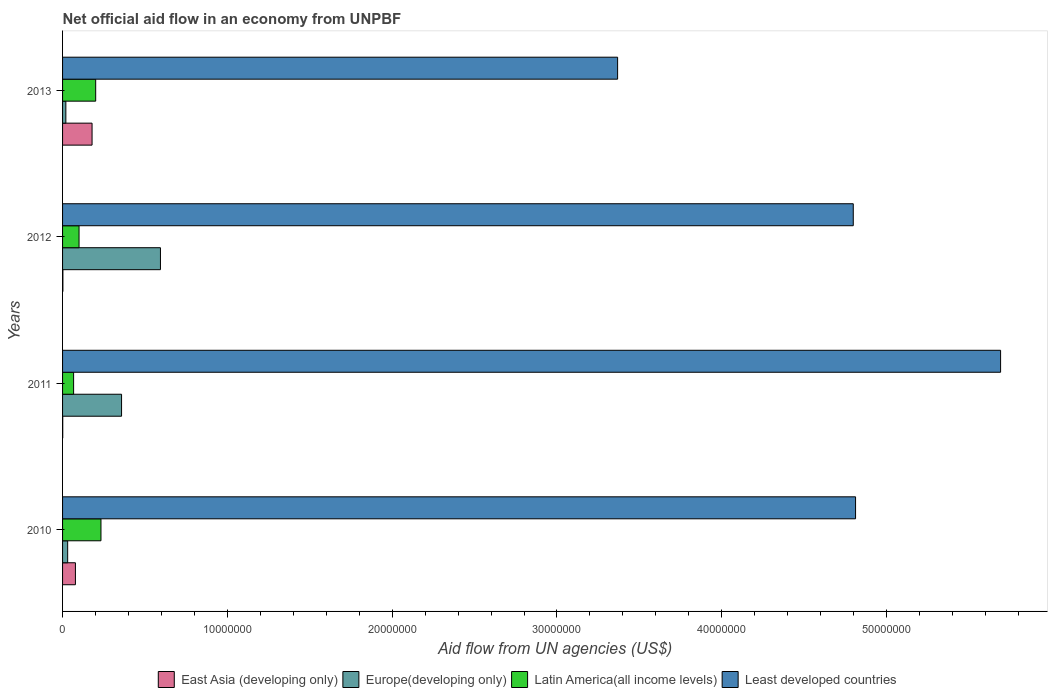How many groups of bars are there?
Offer a terse response. 4. How many bars are there on the 1st tick from the top?
Provide a short and direct response. 4. How many bars are there on the 3rd tick from the bottom?
Ensure brevity in your answer.  4. What is the label of the 3rd group of bars from the top?
Your answer should be very brief. 2011. What is the net official aid flow in Latin America(all income levels) in 2010?
Provide a short and direct response. 2.33e+06. Across all years, what is the maximum net official aid flow in Latin America(all income levels)?
Provide a short and direct response. 2.33e+06. Across all years, what is the minimum net official aid flow in East Asia (developing only)?
Your answer should be very brief. 10000. In which year was the net official aid flow in Latin America(all income levels) maximum?
Keep it short and to the point. 2010. In which year was the net official aid flow in Least developed countries minimum?
Your answer should be compact. 2013. What is the total net official aid flow in East Asia (developing only) in the graph?
Your answer should be very brief. 2.60e+06. What is the difference between the net official aid flow in Europe(developing only) in 2010 and that in 2013?
Offer a terse response. 1.10e+05. What is the difference between the net official aid flow in Europe(developing only) in 2013 and the net official aid flow in Latin America(all income levels) in 2012?
Provide a short and direct response. -8.00e+05. What is the average net official aid flow in Least developed countries per year?
Your answer should be compact. 4.67e+07. In the year 2011, what is the difference between the net official aid flow in East Asia (developing only) and net official aid flow in Least developed countries?
Make the answer very short. -5.69e+07. What is the ratio of the net official aid flow in Least developed countries in 2010 to that in 2013?
Offer a very short reply. 1.43. Is the net official aid flow in Least developed countries in 2011 less than that in 2012?
Keep it short and to the point. No. What is the difference between the highest and the second highest net official aid flow in Least developed countries?
Provide a succinct answer. 8.80e+06. What is the difference between the highest and the lowest net official aid flow in Latin America(all income levels)?
Ensure brevity in your answer.  1.66e+06. Is it the case that in every year, the sum of the net official aid flow in Latin America(all income levels) and net official aid flow in East Asia (developing only) is greater than the sum of net official aid flow in Least developed countries and net official aid flow in Europe(developing only)?
Offer a terse response. No. What does the 4th bar from the top in 2010 represents?
Offer a terse response. East Asia (developing only). What does the 4th bar from the bottom in 2012 represents?
Offer a very short reply. Least developed countries. Is it the case that in every year, the sum of the net official aid flow in East Asia (developing only) and net official aid flow in Latin America(all income levels) is greater than the net official aid flow in Least developed countries?
Your answer should be compact. No. Are all the bars in the graph horizontal?
Your response must be concise. Yes. How many years are there in the graph?
Your response must be concise. 4. What is the difference between two consecutive major ticks on the X-axis?
Offer a terse response. 1.00e+07. Are the values on the major ticks of X-axis written in scientific E-notation?
Provide a short and direct response. No. Does the graph contain any zero values?
Provide a short and direct response. No. Where does the legend appear in the graph?
Your answer should be compact. Bottom center. What is the title of the graph?
Offer a terse response. Net official aid flow in an economy from UNPBF. What is the label or title of the X-axis?
Provide a succinct answer. Aid flow from UN agencies (US$). What is the label or title of the Y-axis?
Offer a very short reply. Years. What is the Aid flow from UN agencies (US$) of East Asia (developing only) in 2010?
Keep it short and to the point. 7.80e+05. What is the Aid flow from UN agencies (US$) of Europe(developing only) in 2010?
Offer a very short reply. 3.10e+05. What is the Aid flow from UN agencies (US$) in Latin America(all income levels) in 2010?
Your answer should be compact. 2.33e+06. What is the Aid flow from UN agencies (US$) in Least developed countries in 2010?
Offer a very short reply. 4.81e+07. What is the Aid flow from UN agencies (US$) of East Asia (developing only) in 2011?
Your answer should be very brief. 10000. What is the Aid flow from UN agencies (US$) in Europe(developing only) in 2011?
Offer a terse response. 3.58e+06. What is the Aid flow from UN agencies (US$) of Latin America(all income levels) in 2011?
Provide a succinct answer. 6.70e+05. What is the Aid flow from UN agencies (US$) of Least developed countries in 2011?
Ensure brevity in your answer.  5.69e+07. What is the Aid flow from UN agencies (US$) in Europe(developing only) in 2012?
Provide a succinct answer. 5.94e+06. What is the Aid flow from UN agencies (US$) of Latin America(all income levels) in 2012?
Your answer should be very brief. 1.00e+06. What is the Aid flow from UN agencies (US$) in Least developed countries in 2012?
Ensure brevity in your answer.  4.80e+07. What is the Aid flow from UN agencies (US$) in East Asia (developing only) in 2013?
Offer a very short reply. 1.79e+06. What is the Aid flow from UN agencies (US$) in Europe(developing only) in 2013?
Give a very brief answer. 2.00e+05. What is the Aid flow from UN agencies (US$) in Latin America(all income levels) in 2013?
Keep it short and to the point. 2.01e+06. What is the Aid flow from UN agencies (US$) in Least developed countries in 2013?
Give a very brief answer. 3.37e+07. Across all years, what is the maximum Aid flow from UN agencies (US$) of East Asia (developing only)?
Give a very brief answer. 1.79e+06. Across all years, what is the maximum Aid flow from UN agencies (US$) of Europe(developing only)?
Give a very brief answer. 5.94e+06. Across all years, what is the maximum Aid flow from UN agencies (US$) in Latin America(all income levels)?
Keep it short and to the point. 2.33e+06. Across all years, what is the maximum Aid flow from UN agencies (US$) of Least developed countries?
Offer a terse response. 5.69e+07. Across all years, what is the minimum Aid flow from UN agencies (US$) of Europe(developing only)?
Provide a succinct answer. 2.00e+05. Across all years, what is the minimum Aid flow from UN agencies (US$) of Latin America(all income levels)?
Keep it short and to the point. 6.70e+05. Across all years, what is the minimum Aid flow from UN agencies (US$) of Least developed countries?
Your answer should be very brief. 3.37e+07. What is the total Aid flow from UN agencies (US$) in East Asia (developing only) in the graph?
Provide a short and direct response. 2.60e+06. What is the total Aid flow from UN agencies (US$) in Europe(developing only) in the graph?
Provide a succinct answer. 1.00e+07. What is the total Aid flow from UN agencies (US$) in Latin America(all income levels) in the graph?
Keep it short and to the point. 6.01e+06. What is the total Aid flow from UN agencies (US$) in Least developed countries in the graph?
Make the answer very short. 1.87e+08. What is the difference between the Aid flow from UN agencies (US$) of East Asia (developing only) in 2010 and that in 2011?
Your response must be concise. 7.70e+05. What is the difference between the Aid flow from UN agencies (US$) of Europe(developing only) in 2010 and that in 2011?
Your answer should be very brief. -3.27e+06. What is the difference between the Aid flow from UN agencies (US$) in Latin America(all income levels) in 2010 and that in 2011?
Provide a short and direct response. 1.66e+06. What is the difference between the Aid flow from UN agencies (US$) in Least developed countries in 2010 and that in 2011?
Ensure brevity in your answer.  -8.80e+06. What is the difference between the Aid flow from UN agencies (US$) in East Asia (developing only) in 2010 and that in 2012?
Ensure brevity in your answer.  7.60e+05. What is the difference between the Aid flow from UN agencies (US$) in Europe(developing only) in 2010 and that in 2012?
Your answer should be very brief. -5.63e+06. What is the difference between the Aid flow from UN agencies (US$) of Latin America(all income levels) in 2010 and that in 2012?
Keep it short and to the point. 1.33e+06. What is the difference between the Aid flow from UN agencies (US$) of East Asia (developing only) in 2010 and that in 2013?
Offer a terse response. -1.01e+06. What is the difference between the Aid flow from UN agencies (US$) in Europe(developing only) in 2010 and that in 2013?
Ensure brevity in your answer.  1.10e+05. What is the difference between the Aid flow from UN agencies (US$) in Latin America(all income levels) in 2010 and that in 2013?
Provide a succinct answer. 3.20e+05. What is the difference between the Aid flow from UN agencies (US$) of Least developed countries in 2010 and that in 2013?
Your answer should be very brief. 1.44e+07. What is the difference between the Aid flow from UN agencies (US$) of East Asia (developing only) in 2011 and that in 2012?
Provide a short and direct response. -10000. What is the difference between the Aid flow from UN agencies (US$) in Europe(developing only) in 2011 and that in 2012?
Keep it short and to the point. -2.36e+06. What is the difference between the Aid flow from UN agencies (US$) of Latin America(all income levels) in 2011 and that in 2012?
Your answer should be compact. -3.30e+05. What is the difference between the Aid flow from UN agencies (US$) of Least developed countries in 2011 and that in 2012?
Your response must be concise. 8.94e+06. What is the difference between the Aid flow from UN agencies (US$) in East Asia (developing only) in 2011 and that in 2013?
Offer a terse response. -1.78e+06. What is the difference between the Aid flow from UN agencies (US$) of Europe(developing only) in 2011 and that in 2013?
Ensure brevity in your answer.  3.38e+06. What is the difference between the Aid flow from UN agencies (US$) in Latin America(all income levels) in 2011 and that in 2013?
Make the answer very short. -1.34e+06. What is the difference between the Aid flow from UN agencies (US$) of Least developed countries in 2011 and that in 2013?
Your answer should be very brief. 2.32e+07. What is the difference between the Aid flow from UN agencies (US$) in East Asia (developing only) in 2012 and that in 2013?
Offer a very short reply. -1.77e+06. What is the difference between the Aid flow from UN agencies (US$) of Europe(developing only) in 2012 and that in 2013?
Provide a succinct answer. 5.74e+06. What is the difference between the Aid flow from UN agencies (US$) of Latin America(all income levels) in 2012 and that in 2013?
Your answer should be very brief. -1.01e+06. What is the difference between the Aid flow from UN agencies (US$) in Least developed countries in 2012 and that in 2013?
Your answer should be very brief. 1.43e+07. What is the difference between the Aid flow from UN agencies (US$) of East Asia (developing only) in 2010 and the Aid flow from UN agencies (US$) of Europe(developing only) in 2011?
Provide a short and direct response. -2.80e+06. What is the difference between the Aid flow from UN agencies (US$) in East Asia (developing only) in 2010 and the Aid flow from UN agencies (US$) in Least developed countries in 2011?
Ensure brevity in your answer.  -5.61e+07. What is the difference between the Aid flow from UN agencies (US$) of Europe(developing only) in 2010 and the Aid flow from UN agencies (US$) of Latin America(all income levels) in 2011?
Make the answer very short. -3.60e+05. What is the difference between the Aid flow from UN agencies (US$) in Europe(developing only) in 2010 and the Aid flow from UN agencies (US$) in Least developed countries in 2011?
Give a very brief answer. -5.66e+07. What is the difference between the Aid flow from UN agencies (US$) of Latin America(all income levels) in 2010 and the Aid flow from UN agencies (US$) of Least developed countries in 2011?
Offer a very short reply. -5.46e+07. What is the difference between the Aid flow from UN agencies (US$) in East Asia (developing only) in 2010 and the Aid flow from UN agencies (US$) in Europe(developing only) in 2012?
Provide a succinct answer. -5.16e+06. What is the difference between the Aid flow from UN agencies (US$) in East Asia (developing only) in 2010 and the Aid flow from UN agencies (US$) in Least developed countries in 2012?
Your response must be concise. -4.72e+07. What is the difference between the Aid flow from UN agencies (US$) of Europe(developing only) in 2010 and the Aid flow from UN agencies (US$) of Latin America(all income levels) in 2012?
Keep it short and to the point. -6.90e+05. What is the difference between the Aid flow from UN agencies (US$) of Europe(developing only) in 2010 and the Aid flow from UN agencies (US$) of Least developed countries in 2012?
Ensure brevity in your answer.  -4.77e+07. What is the difference between the Aid flow from UN agencies (US$) of Latin America(all income levels) in 2010 and the Aid flow from UN agencies (US$) of Least developed countries in 2012?
Offer a terse response. -4.56e+07. What is the difference between the Aid flow from UN agencies (US$) of East Asia (developing only) in 2010 and the Aid flow from UN agencies (US$) of Europe(developing only) in 2013?
Make the answer very short. 5.80e+05. What is the difference between the Aid flow from UN agencies (US$) in East Asia (developing only) in 2010 and the Aid flow from UN agencies (US$) in Latin America(all income levels) in 2013?
Your answer should be compact. -1.23e+06. What is the difference between the Aid flow from UN agencies (US$) of East Asia (developing only) in 2010 and the Aid flow from UN agencies (US$) of Least developed countries in 2013?
Make the answer very short. -3.29e+07. What is the difference between the Aid flow from UN agencies (US$) in Europe(developing only) in 2010 and the Aid flow from UN agencies (US$) in Latin America(all income levels) in 2013?
Keep it short and to the point. -1.70e+06. What is the difference between the Aid flow from UN agencies (US$) in Europe(developing only) in 2010 and the Aid flow from UN agencies (US$) in Least developed countries in 2013?
Ensure brevity in your answer.  -3.34e+07. What is the difference between the Aid flow from UN agencies (US$) of Latin America(all income levels) in 2010 and the Aid flow from UN agencies (US$) of Least developed countries in 2013?
Keep it short and to the point. -3.14e+07. What is the difference between the Aid flow from UN agencies (US$) in East Asia (developing only) in 2011 and the Aid flow from UN agencies (US$) in Europe(developing only) in 2012?
Your answer should be very brief. -5.93e+06. What is the difference between the Aid flow from UN agencies (US$) in East Asia (developing only) in 2011 and the Aid flow from UN agencies (US$) in Latin America(all income levels) in 2012?
Your answer should be very brief. -9.90e+05. What is the difference between the Aid flow from UN agencies (US$) of East Asia (developing only) in 2011 and the Aid flow from UN agencies (US$) of Least developed countries in 2012?
Make the answer very short. -4.80e+07. What is the difference between the Aid flow from UN agencies (US$) of Europe(developing only) in 2011 and the Aid flow from UN agencies (US$) of Latin America(all income levels) in 2012?
Provide a short and direct response. 2.58e+06. What is the difference between the Aid flow from UN agencies (US$) of Europe(developing only) in 2011 and the Aid flow from UN agencies (US$) of Least developed countries in 2012?
Give a very brief answer. -4.44e+07. What is the difference between the Aid flow from UN agencies (US$) in Latin America(all income levels) in 2011 and the Aid flow from UN agencies (US$) in Least developed countries in 2012?
Your answer should be very brief. -4.73e+07. What is the difference between the Aid flow from UN agencies (US$) in East Asia (developing only) in 2011 and the Aid flow from UN agencies (US$) in Europe(developing only) in 2013?
Provide a short and direct response. -1.90e+05. What is the difference between the Aid flow from UN agencies (US$) in East Asia (developing only) in 2011 and the Aid flow from UN agencies (US$) in Least developed countries in 2013?
Keep it short and to the point. -3.37e+07. What is the difference between the Aid flow from UN agencies (US$) in Europe(developing only) in 2011 and the Aid flow from UN agencies (US$) in Latin America(all income levels) in 2013?
Keep it short and to the point. 1.57e+06. What is the difference between the Aid flow from UN agencies (US$) of Europe(developing only) in 2011 and the Aid flow from UN agencies (US$) of Least developed countries in 2013?
Offer a terse response. -3.01e+07. What is the difference between the Aid flow from UN agencies (US$) in Latin America(all income levels) in 2011 and the Aid flow from UN agencies (US$) in Least developed countries in 2013?
Your response must be concise. -3.30e+07. What is the difference between the Aid flow from UN agencies (US$) in East Asia (developing only) in 2012 and the Aid flow from UN agencies (US$) in Latin America(all income levels) in 2013?
Ensure brevity in your answer.  -1.99e+06. What is the difference between the Aid flow from UN agencies (US$) of East Asia (developing only) in 2012 and the Aid flow from UN agencies (US$) of Least developed countries in 2013?
Keep it short and to the point. -3.37e+07. What is the difference between the Aid flow from UN agencies (US$) in Europe(developing only) in 2012 and the Aid flow from UN agencies (US$) in Latin America(all income levels) in 2013?
Offer a very short reply. 3.93e+06. What is the difference between the Aid flow from UN agencies (US$) in Europe(developing only) in 2012 and the Aid flow from UN agencies (US$) in Least developed countries in 2013?
Provide a short and direct response. -2.77e+07. What is the difference between the Aid flow from UN agencies (US$) in Latin America(all income levels) in 2012 and the Aid flow from UN agencies (US$) in Least developed countries in 2013?
Ensure brevity in your answer.  -3.27e+07. What is the average Aid flow from UN agencies (US$) in East Asia (developing only) per year?
Provide a succinct answer. 6.50e+05. What is the average Aid flow from UN agencies (US$) in Europe(developing only) per year?
Your answer should be very brief. 2.51e+06. What is the average Aid flow from UN agencies (US$) of Latin America(all income levels) per year?
Provide a short and direct response. 1.50e+06. What is the average Aid flow from UN agencies (US$) in Least developed countries per year?
Your answer should be compact. 4.67e+07. In the year 2010, what is the difference between the Aid flow from UN agencies (US$) of East Asia (developing only) and Aid flow from UN agencies (US$) of Latin America(all income levels)?
Provide a short and direct response. -1.55e+06. In the year 2010, what is the difference between the Aid flow from UN agencies (US$) of East Asia (developing only) and Aid flow from UN agencies (US$) of Least developed countries?
Give a very brief answer. -4.73e+07. In the year 2010, what is the difference between the Aid flow from UN agencies (US$) of Europe(developing only) and Aid flow from UN agencies (US$) of Latin America(all income levels)?
Your answer should be very brief. -2.02e+06. In the year 2010, what is the difference between the Aid flow from UN agencies (US$) in Europe(developing only) and Aid flow from UN agencies (US$) in Least developed countries?
Provide a short and direct response. -4.78e+07. In the year 2010, what is the difference between the Aid flow from UN agencies (US$) of Latin America(all income levels) and Aid flow from UN agencies (US$) of Least developed countries?
Give a very brief answer. -4.58e+07. In the year 2011, what is the difference between the Aid flow from UN agencies (US$) of East Asia (developing only) and Aid flow from UN agencies (US$) of Europe(developing only)?
Offer a very short reply. -3.57e+06. In the year 2011, what is the difference between the Aid flow from UN agencies (US$) of East Asia (developing only) and Aid flow from UN agencies (US$) of Latin America(all income levels)?
Your answer should be compact. -6.60e+05. In the year 2011, what is the difference between the Aid flow from UN agencies (US$) in East Asia (developing only) and Aid flow from UN agencies (US$) in Least developed countries?
Give a very brief answer. -5.69e+07. In the year 2011, what is the difference between the Aid flow from UN agencies (US$) of Europe(developing only) and Aid flow from UN agencies (US$) of Latin America(all income levels)?
Offer a very short reply. 2.91e+06. In the year 2011, what is the difference between the Aid flow from UN agencies (US$) of Europe(developing only) and Aid flow from UN agencies (US$) of Least developed countries?
Provide a succinct answer. -5.33e+07. In the year 2011, what is the difference between the Aid flow from UN agencies (US$) in Latin America(all income levels) and Aid flow from UN agencies (US$) in Least developed countries?
Provide a short and direct response. -5.62e+07. In the year 2012, what is the difference between the Aid flow from UN agencies (US$) of East Asia (developing only) and Aid flow from UN agencies (US$) of Europe(developing only)?
Give a very brief answer. -5.92e+06. In the year 2012, what is the difference between the Aid flow from UN agencies (US$) of East Asia (developing only) and Aid flow from UN agencies (US$) of Latin America(all income levels)?
Make the answer very short. -9.80e+05. In the year 2012, what is the difference between the Aid flow from UN agencies (US$) in East Asia (developing only) and Aid flow from UN agencies (US$) in Least developed countries?
Ensure brevity in your answer.  -4.80e+07. In the year 2012, what is the difference between the Aid flow from UN agencies (US$) in Europe(developing only) and Aid flow from UN agencies (US$) in Latin America(all income levels)?
Provide a short and direct response. 4.94e+06. In the year 2012, what is the difference between the Aid flow from UN agencies (US$) of Europe(developing only) and Aid flow from UN agencies (US$) of Least developed countries?
Your answer should be very brief. -4.20e+07. In the year 2012, what is the difference between the Aid flow from UN agencies (US$) in Latin America(all income levels) and Aid flow from UN agencies (US$) in Least developed countries?
Provide a short and direct response. -4.70e+07. In the year 2013, what is the difference between the Aid flow from UN agencies (US$) in East Asia (developing only) and Aid flow from UN agencies (US$) in Europe(developing only)?
Ensure brevity in your answer.  1.59e+06. In the year 2013, what is the difference between the Aid flow from UN agencies (US$) in East Asia (developing only) and Aid flow from UN agencies (US$) in Least developed countries?
Provide a succinct answer. -3.19e+07. In the year 2013, what is the difference between the Aid flow from UN agencies (US$) of Europe(developing only) and Aid flow from UN agencies (US$) of Latin America(all income levels)?
Offer a terse response. -1.81e+06. In the year 2013, what is the difference between the Aid flow from UN agencies (US$) in Europe(developing only) and Aid flow from UN agencies (US$) in Least developed countries?
Provide a short and direct response. -3.35e+07. In the year 2013, what is the difference between the Aid flow from UN agencies (US$) in Latin America(all income levels) and Aid flow from UN agencies (US$) in Least developed countries?
Offer a terse response. -3.17e+07. What is the ratio of the Aid flow from UN agencies (US$) in Europe(developing only) in 2010 to that in 2011?
Ensure brevity in your answer.  0.09. What is the ratio of the Aid flow from UN agencies (US$) of Latin America(all income levels) in 2010 to that in 2011?
Give a very brief answer. 3.48. What is the ratio of the Aid flow from UN agencies (US$) of Least developed countries in 2010 to that in 2011?
Give a very brief answer. 0.85. What is the ratio of the Aid flow from UN agencies (US$) of East Asia (developing only) in 2010 to that in 2012?
Keep it short and to the point. 39. What is the ratio of the Aid flow from UN agencies (US$) in Europe(developing only) in 2010 to that in 2012?
Keep it short and to the point. 0.05. What is the ratio of the Aid flow from UN agencies (US$) in Latin America(all income levels) in 2010 to that in 2012?
Your answer should be very brief. 2.33. What is the ratio of the Aid flow from UN agencies (US$) in East Asia (developing only) in 2010 to that in 2013?
Provide a succinct answer. 0.44. What is the ratio of the Aid flow from UN agencies (US$) in Europe(developing only) in 2010 to that in 2013?
Your answer should be very brief. 1.55. What is the ratio of the Aid flow from UN agencies (US$) of Latin America(all income levels) in 2010 to that in 2013?
Make the answer very short. 1.16. What is the ratio of the Aid flow from UN agencies (US$) of Least developed countries in 2010 to that in 2013?
Offer a terse response. 1.43. What is the ratio of the Aid flow from UN agencies (US$) of Europe(developing only) in 2011 to that in 2012?
Offer a terse response. 0.6. What is the ratio of the Aid flow from UN agencies (US$) in Latin America(all income levels) in 2011 to that in 2012?
Make the answer very short. 0.67. What is the ratio of the Aid flow from UN agencies (US$) in Least developed countries in 2011 to that in 2012?
Make the answer very short. 1.19. What is the ratio of the Aid flow from UN agencies (US$) in East Asia (developing only) in 2011 to that in 2013?
Give a very brief answer. 0.01. What is the ratio of the Aid flow from UN agencies (US$) of Europe(developing only) in 2011 to that in 2013?
Your answer should be compact. 17.9. What is the ratio of the Aid flow from UN agencies (US$) in Least developed countries in 2011 to that in 2013?
Ensure brevity in your answer.  1.69. What is the ratio of the Aid flow from UN agencies (US$) in East Asia (developing only) in 2012 to that in 2013?
Keep it short and to the point. 0.01. What is the ratio of the Aid flow from UN agencies (US$) in Europe(developing only) in 2012 to that in 2013?
Offer a terse response. 29.7. What is the ratio of the Aid flow from UN agencies (US$) of Latin America(all income levels) in 2012 to that in 2013?
Your answer should be compact. 0.5. What is the ratio of the Aid flow from UN agencies (US$) in Least developed countries in 2012 to that in 2013?
Your answer should be compact. 1.42. What is the difference between the highest and the second highest Aid flow from UN agencies (US$) in East Asia (developing only)?
Give a very brief answer. 1.01e+06. What is the difference between the highest and the second highest Aid flow from UN agencies (US$) in Europe(developing only)?
Offer a terse response. 2.36e+06. What is the difference between the highest and the second highest Aid flow from UN agencies (US$) of Least developed countries?
Provide a short and direct response. 8.80e+06. What is the difference between the highest and the lowest Aid flow from UN agencies (US$) in East Asia (developing only)?
Provide a short and direct response. 1.78e+06. What is the difference between the highest and the lowest Aid flow from UN agencies (US$) of Europe(developing only)?
Your answer should be compact. 5.74e+06. What is the difference between the highest and the lowest Aid flow from UN agencies (US$) of Latin America(all income levels)?
Your response must be concise. 1.66e+06. What is the difference between the highest and the lowest Aid flow from UN agencies (US$) in Least developed countries?
Give a very brief answer. 2.32e+07. 